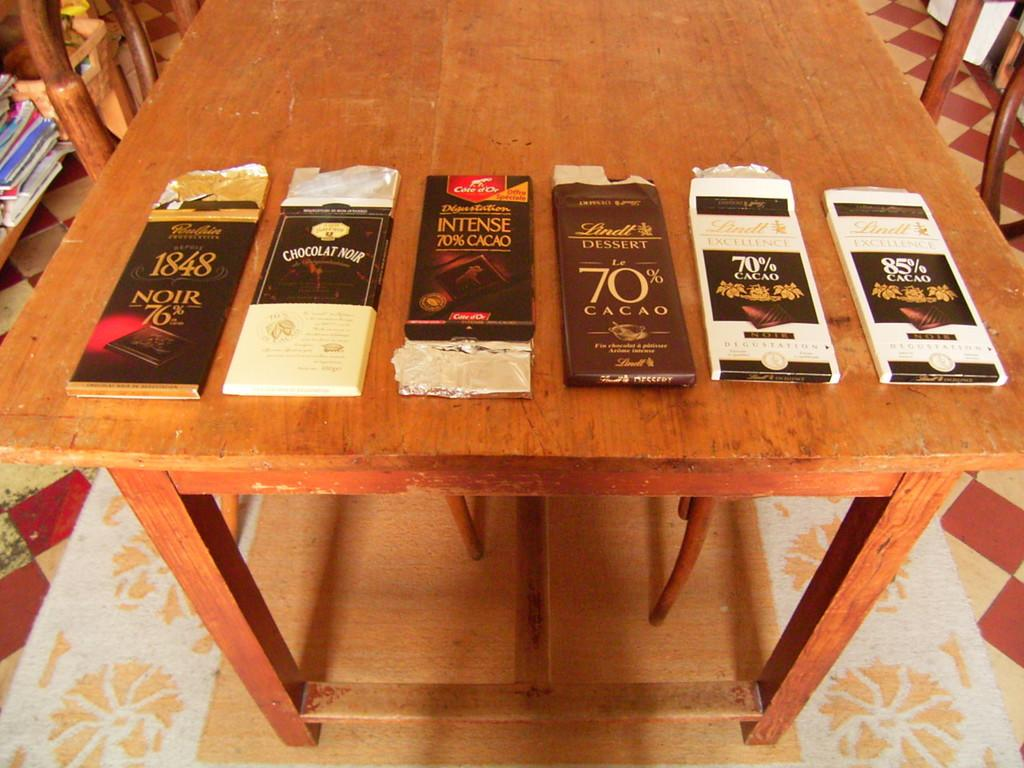<image>
Summarize the visual content of the image. A variety of packets of Cacao for tasting 